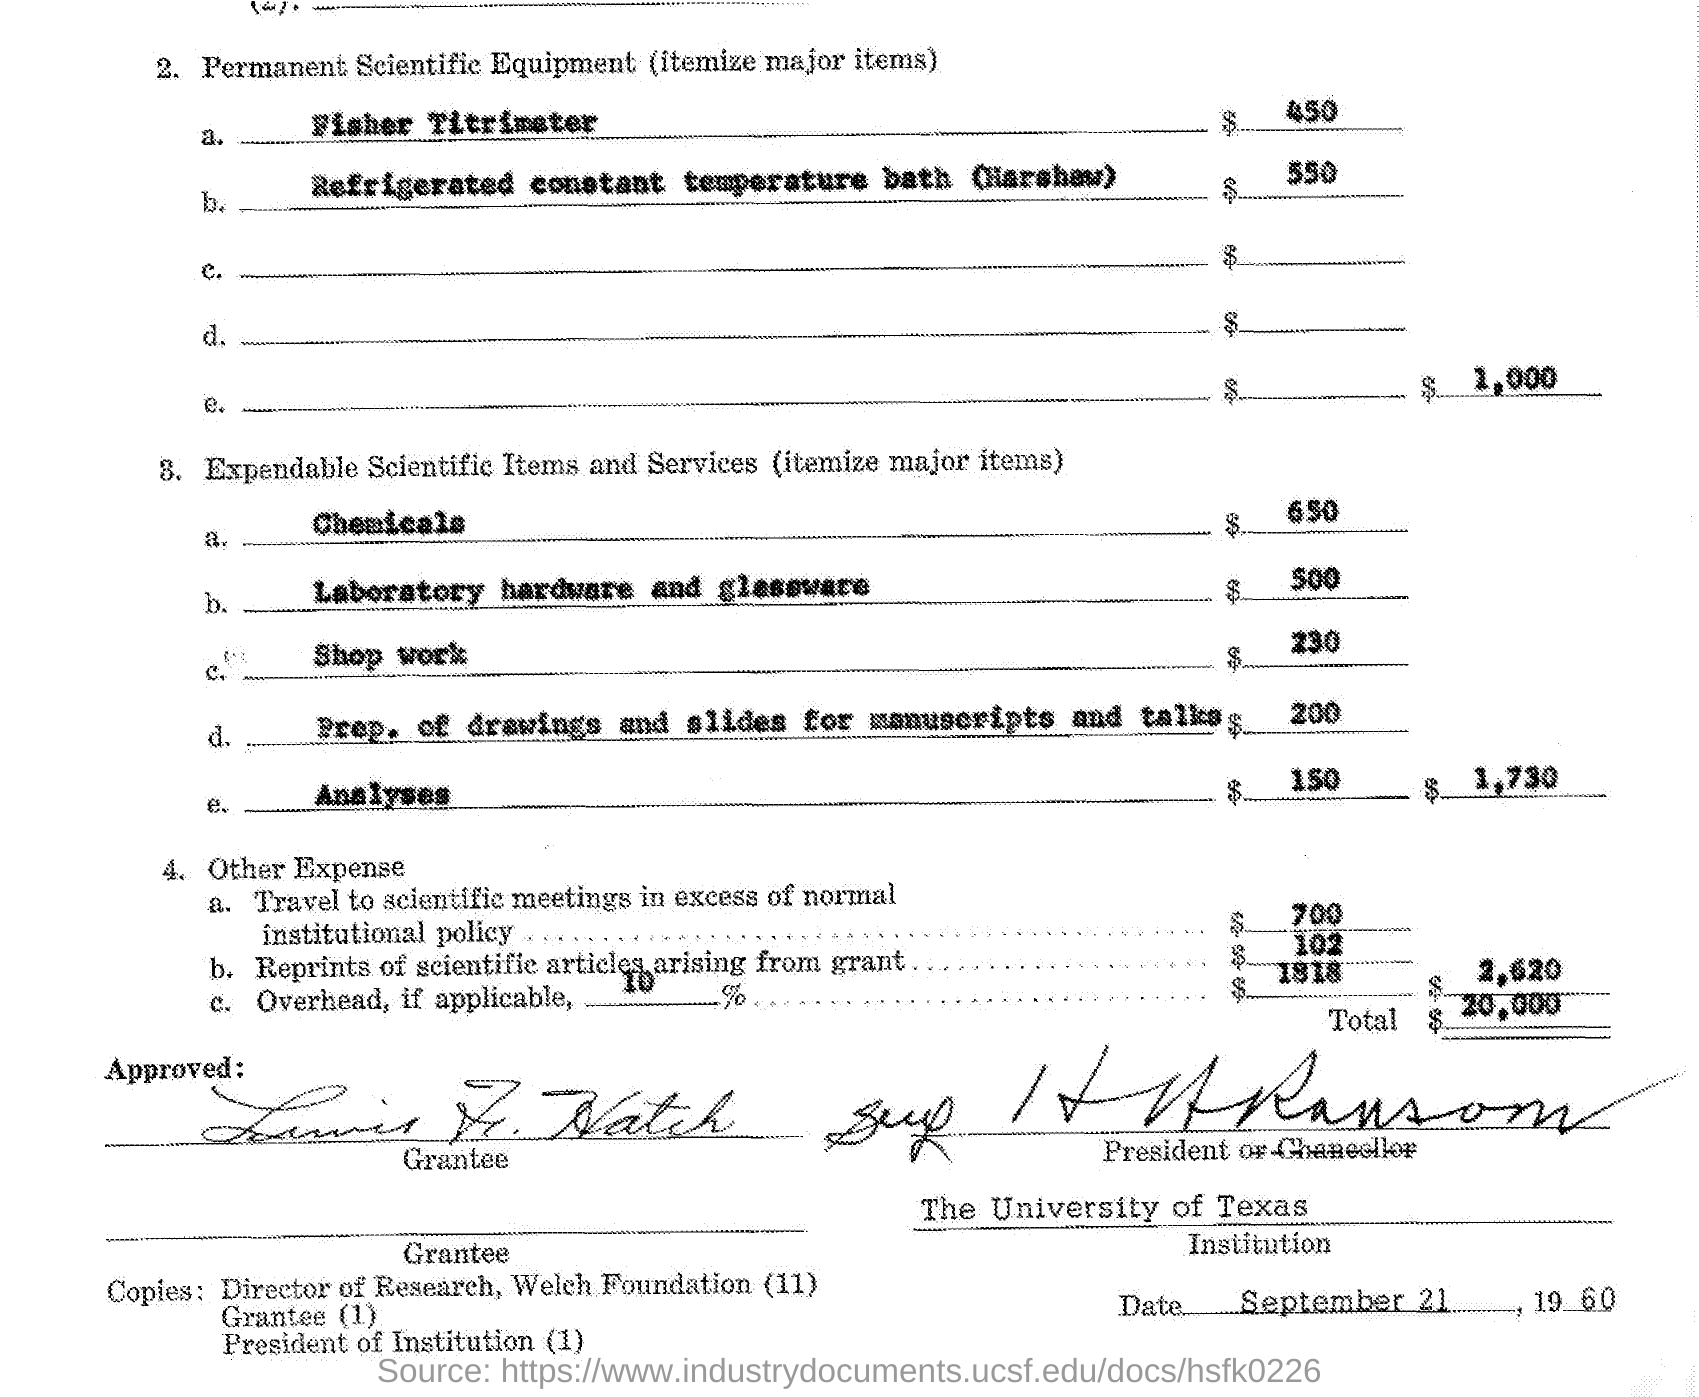What is the expense for Fisher Titrimeter?
Your answer should be very brief. $450. What is the expense for Chemicals?
Offer a terse response. $650. What is the expense for Laboratory hardware and glassware?
Keep it short and to the point. $500. What is the expense for Shop work?
Keep it short and to the point. $230. What is the expense for Prep. of drawings and slides for manuscripts and talks?
Offer a terse response. $200. What is the Total?
Provide a short and direct response. $20,000. What is the expense for Reprints of scientific articles arising from grant?
Your answer should be very brief. $102. 